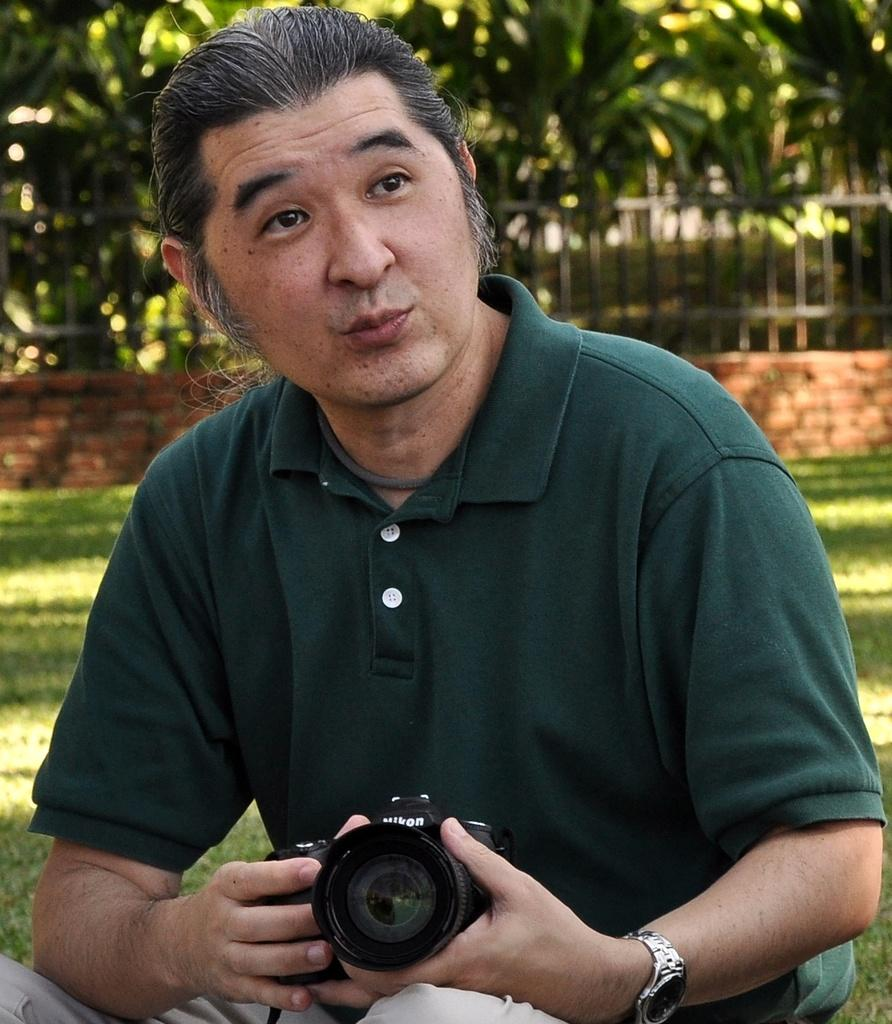Who is present in the image? There is a man in the image. What is the man doing in the image? The man is sitting on the grass in the image. What is the man holding in the image? The man is holding a camera with his hands in the image. What accessory is the man wearing in the image? The man is wearing a watch in the image. What can be seen in the background of the image? There are plants visible in the background of the image. What type of carriage can be seen in the image? There is no carriage present in the image. What camping equipment is visible in the image? There is no camping equipment visible in the image. 